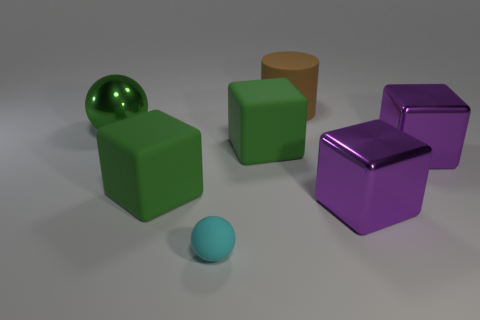Is there any other thing that has the same size as the cyan sphere?
Give a very brief answer. No. Is there a big blue sphere made of the same material as the small sphere?
Your response must be concise. No. What material is the green sphere that is the same size as the matte cylinder?
Your response must be concise. Metal. There is a rubber object that is both to the right of the tiny cyan object and in front of the large metallic sphere; what color is it?
Your answer should be compact. Green. Is the number of tiny cyan things that are behind the green shiny object less than the number of large brown objects that are behind the cylinder?
Provide a short and direct response. No. What number of matte objects have the same shape as the green metallic object?
Keep it short and to the point. 1. The cylinder that is made of the same material as the small thing is what size?
Provide a short and direct response. Large. The sphere that is right of the metallic object on the left side of the brown matte cylinder is what color?
Offer a terse response. Cyan. There is a tiny thing; does it have the same shape as the large metal thing left of the matte cylinder?
Provide a short and direct response. Yes. How many balls are the same size as the brown matte object?
Your answer should be compact. 1. 